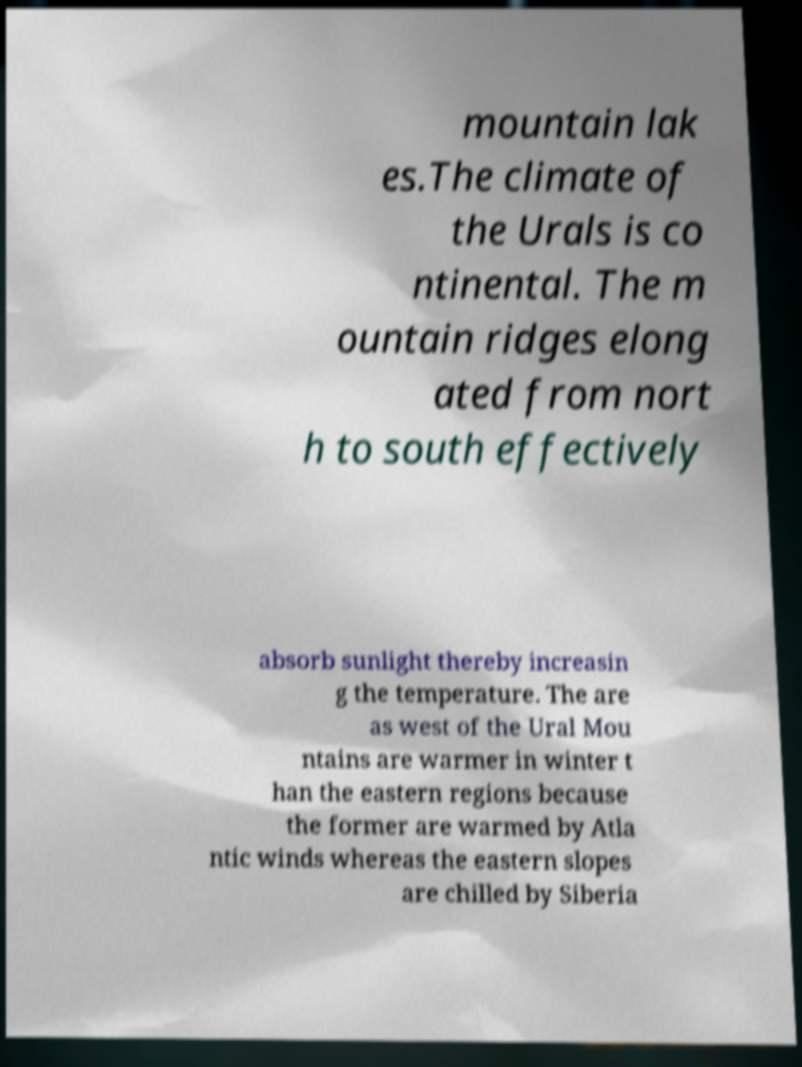Can you read and provide the text displayed in the image?This photo seems to have some interesting text. Can you extract and type it out for me? mountain lak es.The climate of the Urals is co ntinental. The m ountain ridges elong ated from nort h to south effectively absorb sunlight thereby increasin g the temperature. The are as west of the Ural Mou ntains are warmer in winter t han the eastern regions because the former are warmed by Atla ntic winds whereas the eastern slopes are chilled by Siberia 